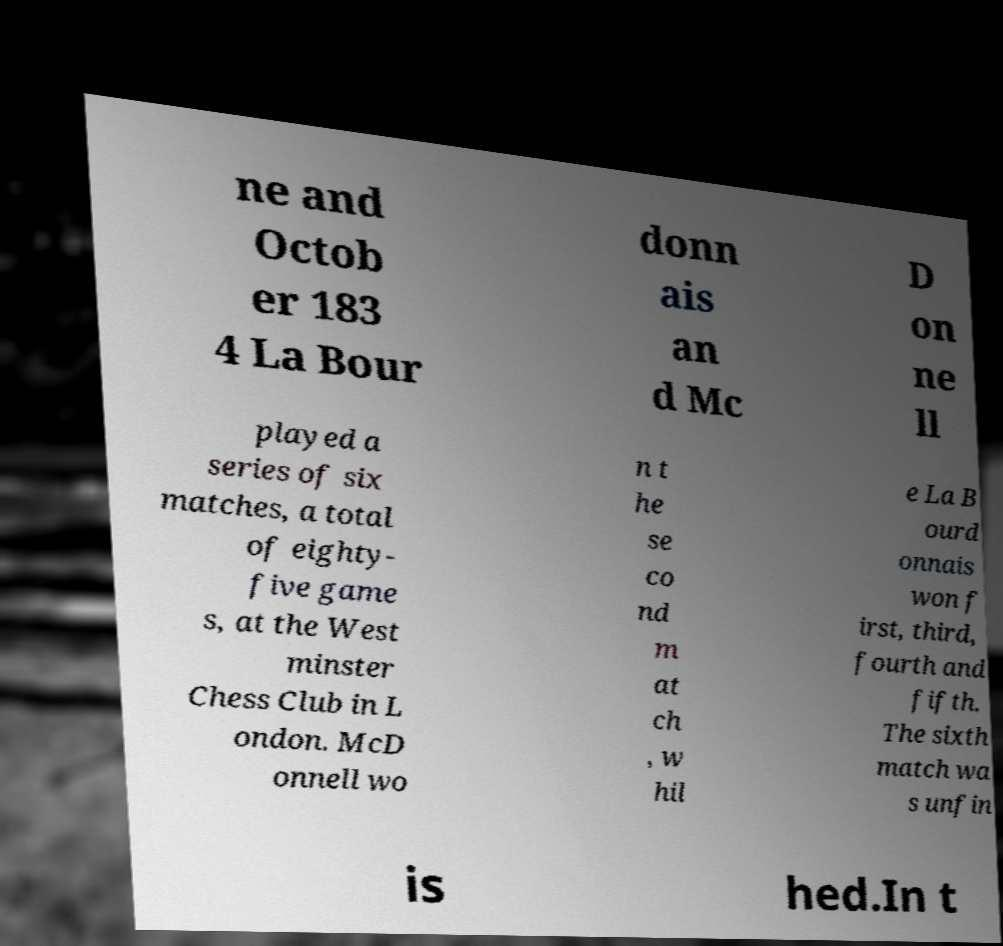Could you assist in decoding the text presented in this image and type it out clearly? ne and Octob er 183 4 La Bour donn ais an d Mc D on ne ll played a series of six matches, a total of eighty- five game s, at the West minster Chess Club in L ondon. McD onnell wo n t he se co nd m at ch , w hil e La B ourd onnais won f irst, third, fourth and fifth. The sixth match wa s unfin is hed.In t 